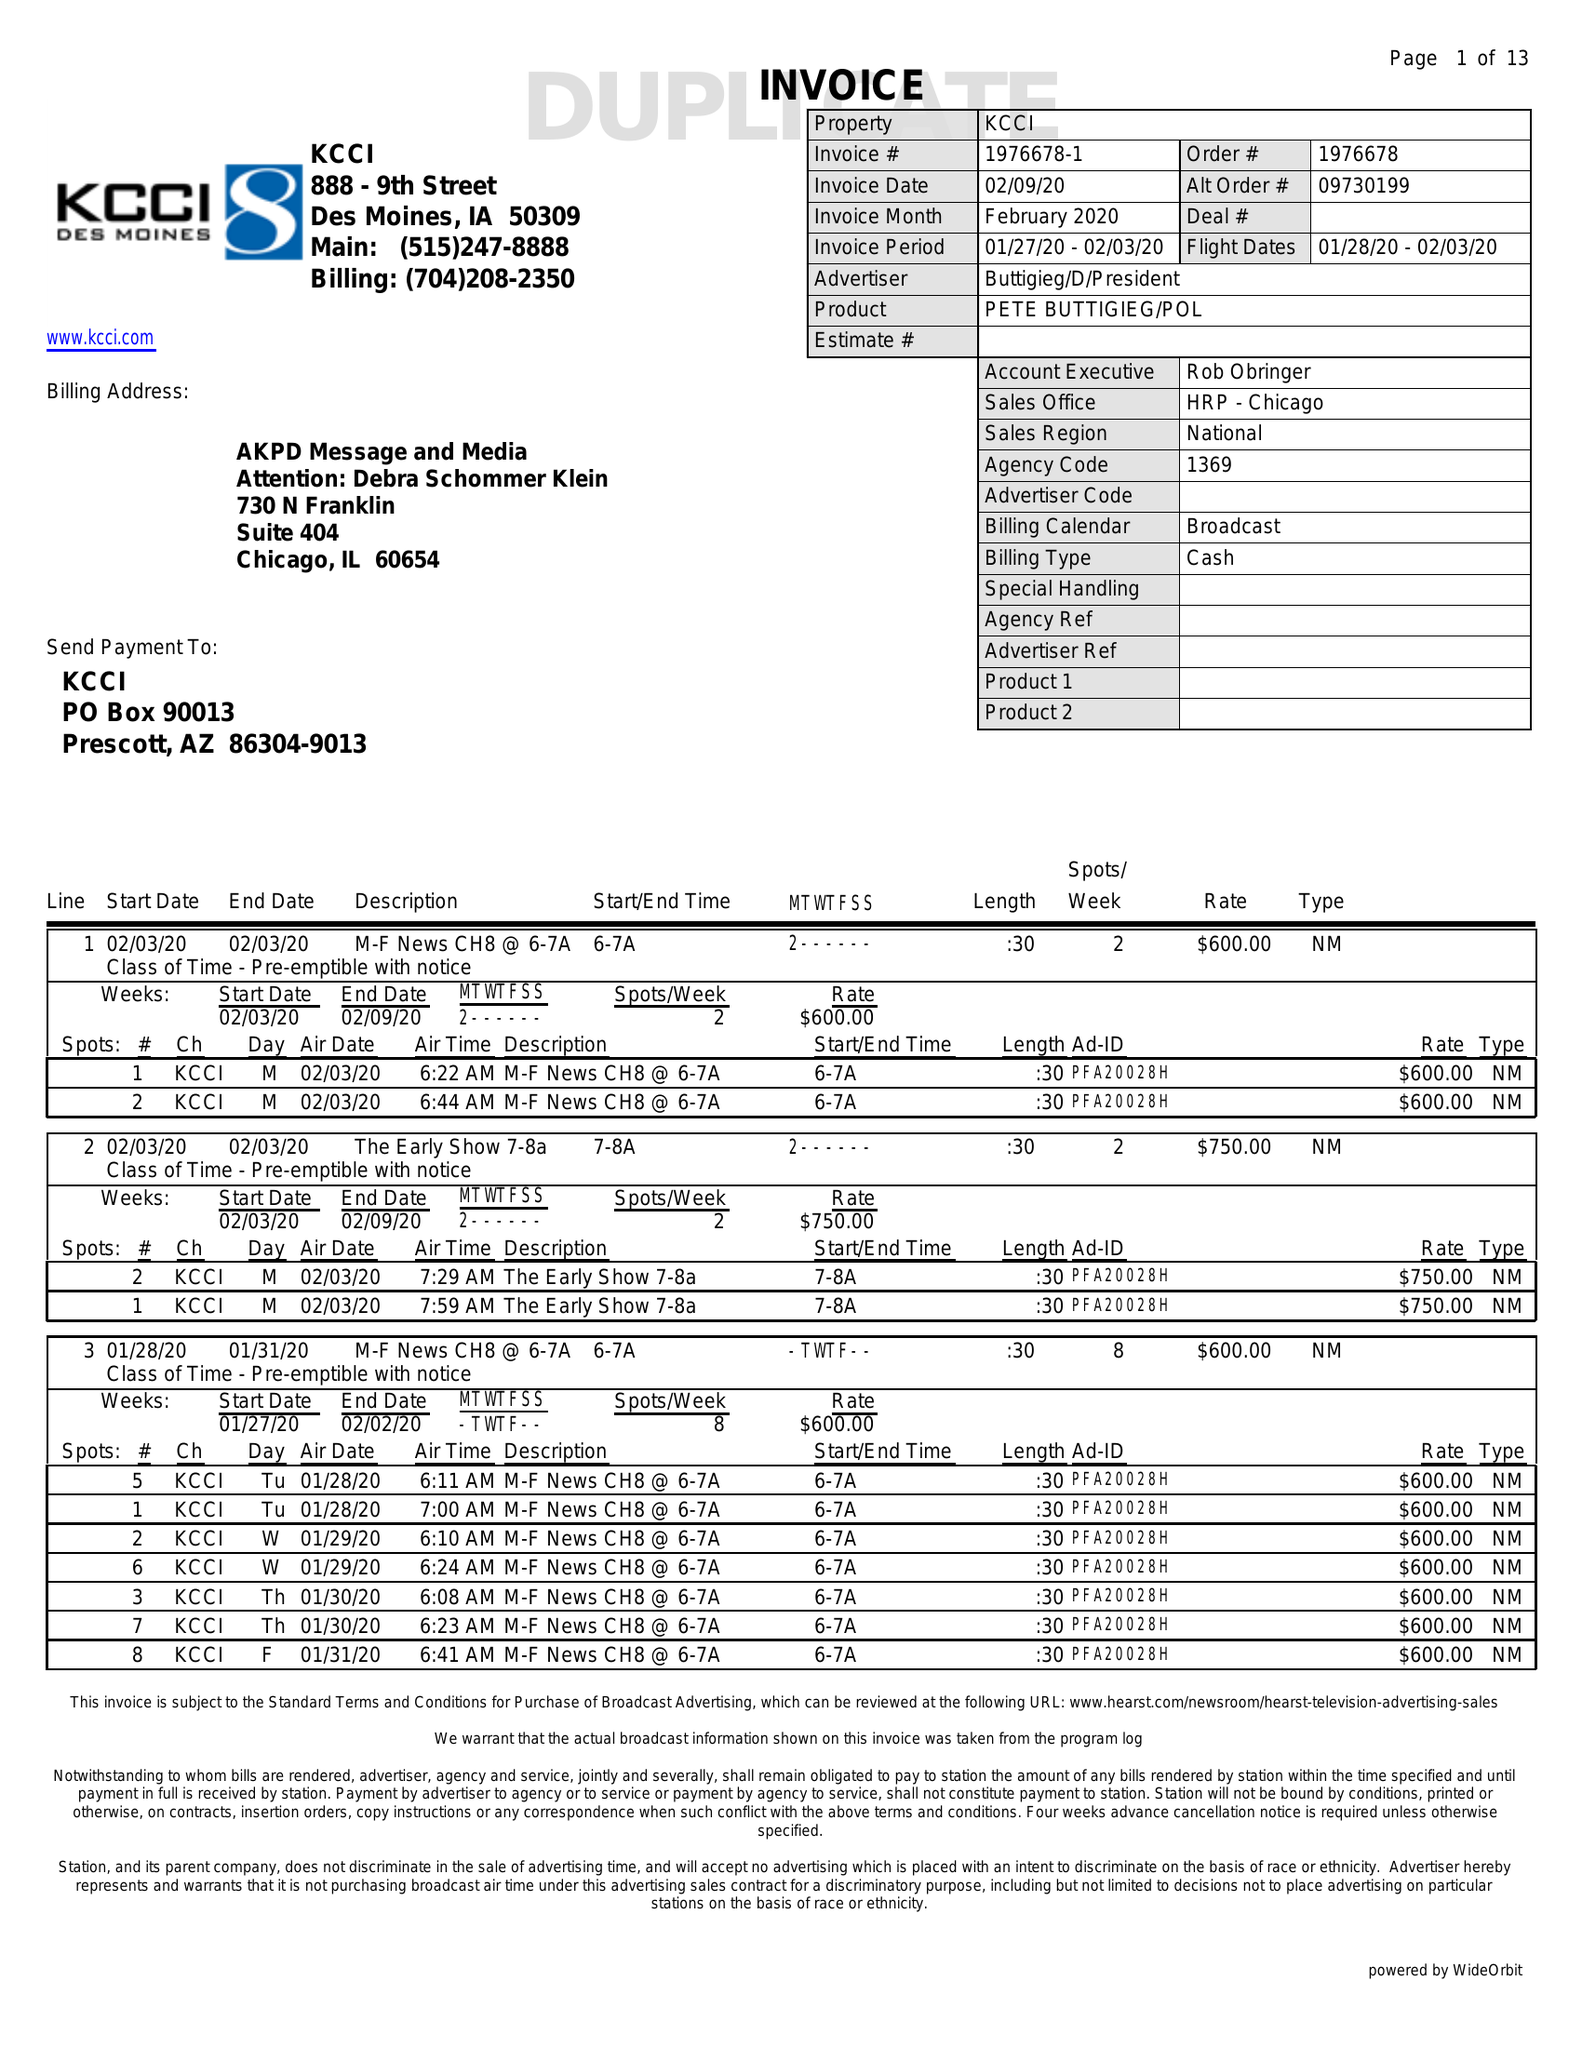What is the value for the gross_amount?
Answer the question using a single word or phrase. 107675.00 